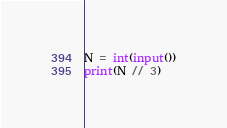<code> <loc_0><loc_0><loc_500><loc_500><_Python_>N = int(input())
print(N // 3)</code> 